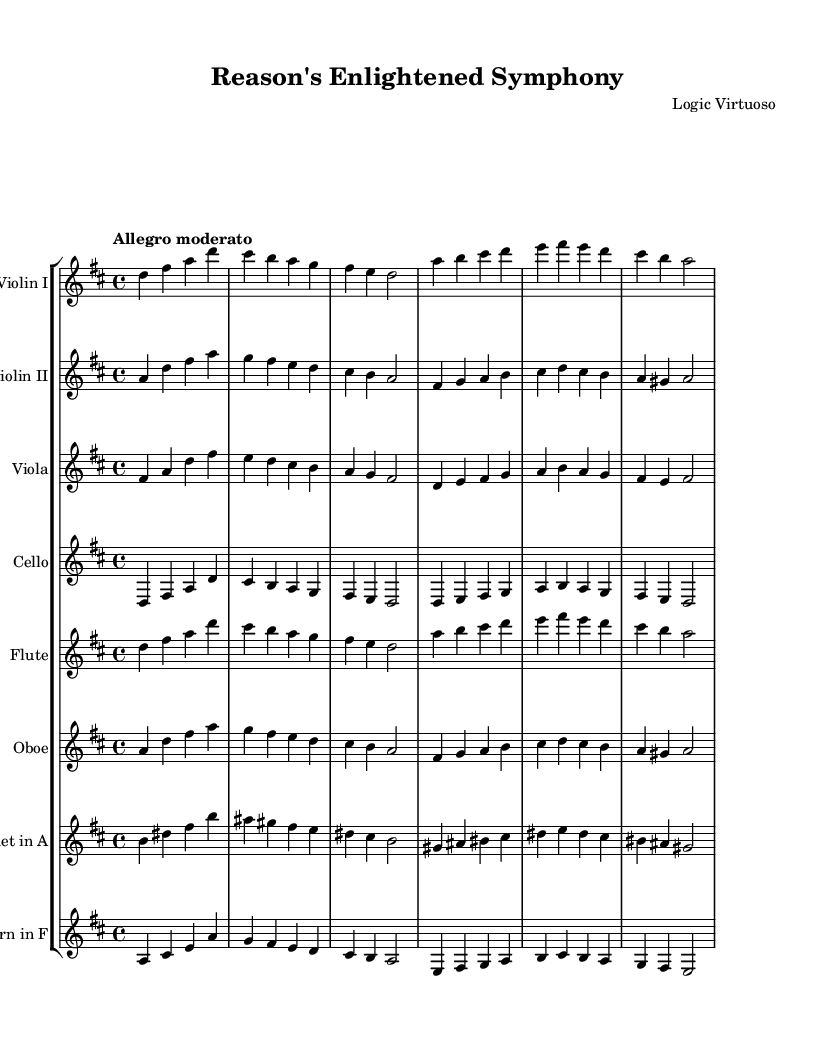What is the key signature of this music? The key signature is indicated at the beginning of the staff and shows two sharps. The notes corresponding to these sharps are F# and C#.
Answer: D major What is the time signature of this music? The time signature is located near the beginning of the staff notation, shown as 4/4. This means there are four beats in each measure, and a quarter note gets one beat.
Answer: 4/4 What is the tempo marking given for this piece? The tempo marking is also found at the beginning of the score, instructing the performers to play at a moderate speed. In this case, it states "Allegro moderato."
Answer: Allegro moderato How many measures are in the entire piece? Begin by counting the groupings of bars separated by vertical lines, which represent measures. Upon counting, the total number of measures turns out to be 16.
Answer: 16 Which instruments are included in this score? The instruments are listed at the beginning of each staff, revealing a range of orchestral instruments from strings to woodwinds. They include Violin I, Violin II, Viola, Cello, Flute, Oboe, Clarinet, and Horn.
Answer: Violin I, Violin II, Viola, Cello, Flute, Oboe, Clarinet, Horn What is the range of the lowest instrument in this score? The lowest instrument is the Cello, whose music is written an octave lower than the middle C note in the piano, reaching down to an A note and spanning approximately a fourth below.
Answer: A How does the melody in the Violin I part relate to the harmony in the Viola part? To understand the relation, compare the notes played in both parts. The Violin I outlines a melody that often harmonizes or complements the Viola part's underlying notes, creating a rich textural relationship typical in Romantic compositions. This is established through both instruments sharing common notes like D and A, establishing a harmonious dialogue.
Answer: Harmonizes 